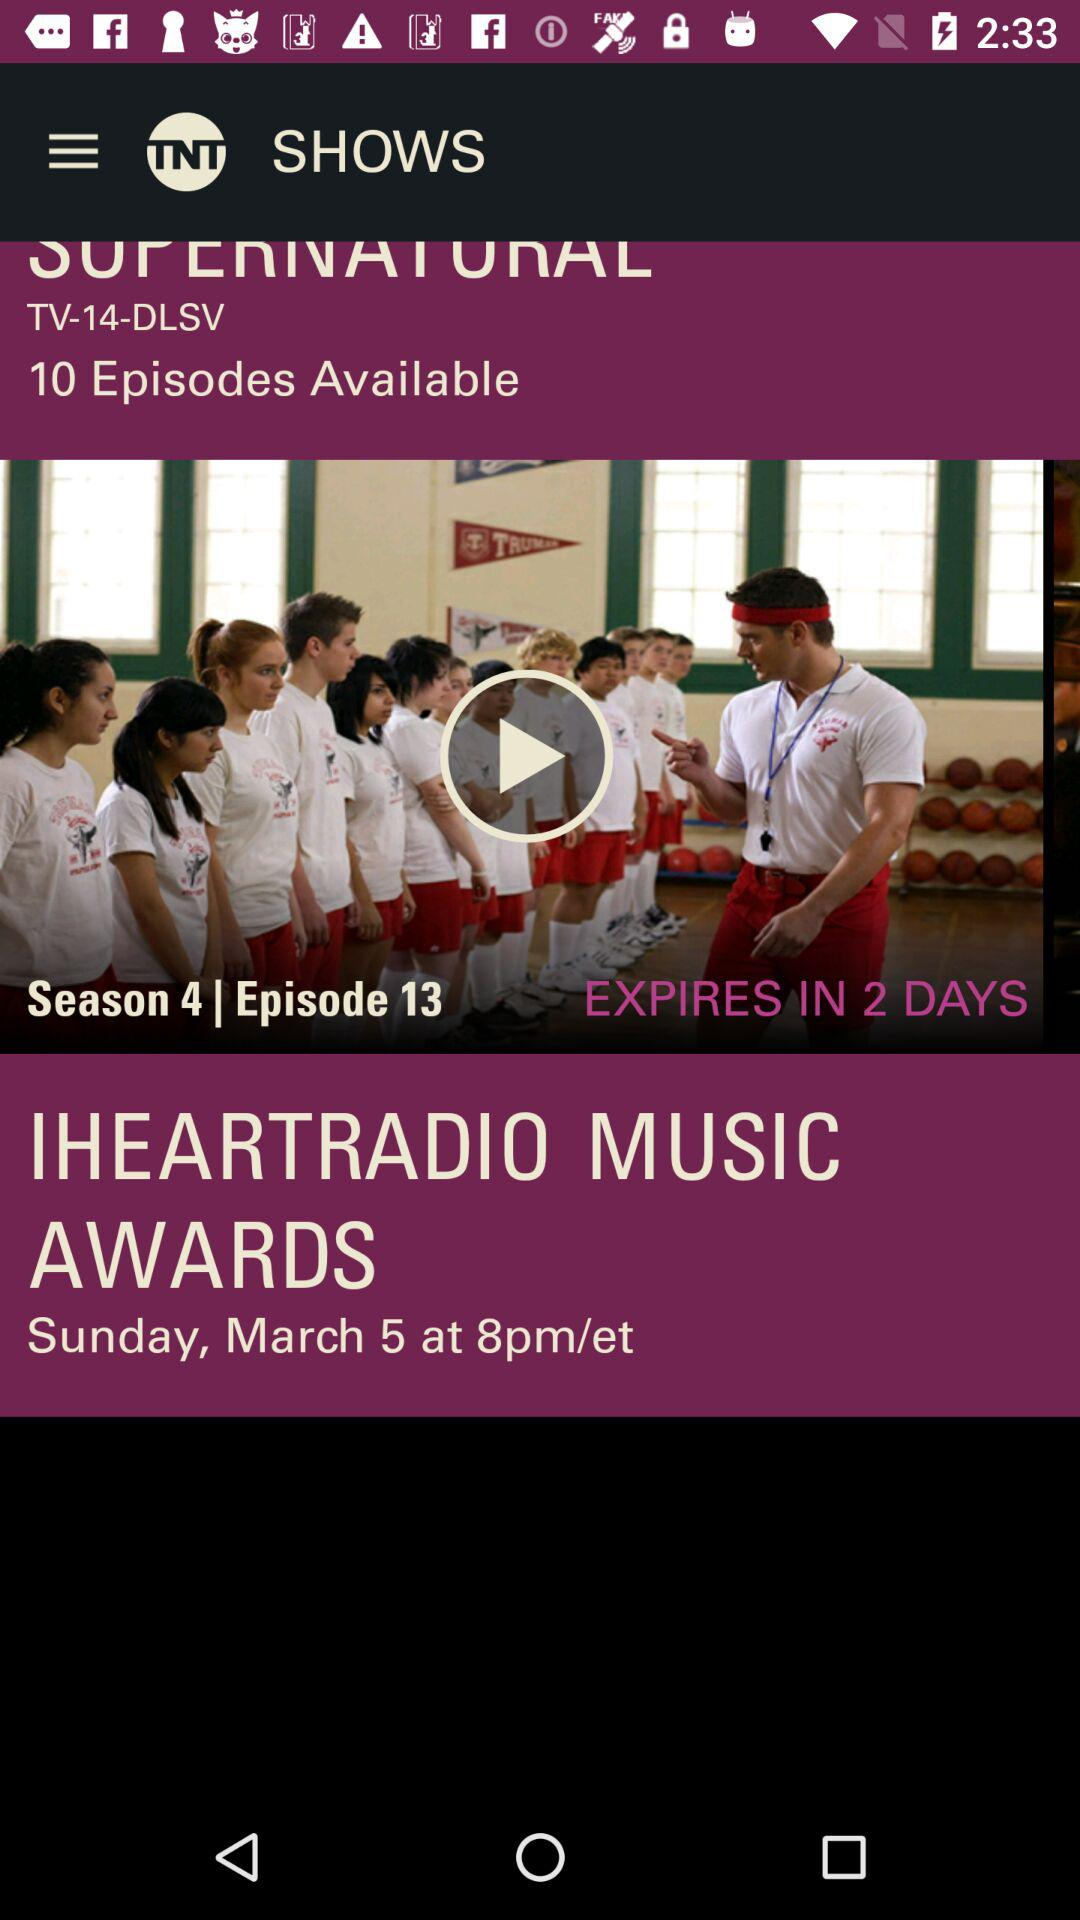How many episodes of Supernatural are available?
Answer the question using a single word or phrase. 10 